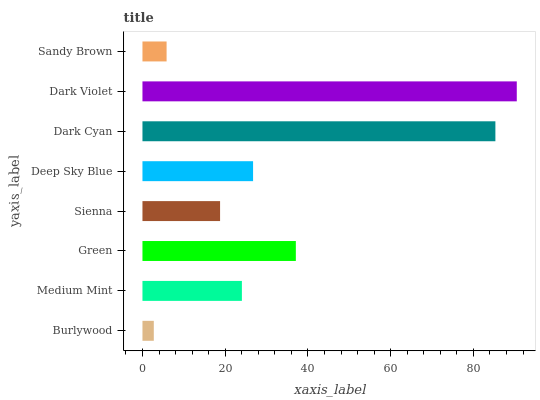Is Burlywood the minimum?
Answer yes or no. Yes. Is Dark Violet the maximum?
Answer yes or no. Yes. Is Medium Mint the minimum?
Answer yes or no. No. Is Medium Mint the maximum?
Answer yes or no. No. Is Medium Mint greater than Burlywood?
Answer yes or no. Yes. Is Burlywood less than Medium Mint?
Answer yes or no. Yes. Is Burlywood greater than Medium Mint?
Answer yes or no. No. Is Medium Mint less than Burlywood?
Answer yes or no. No. Is Deep Sky Blue the high median?
Answer yes or no. Yes. Is Medium Mint the low median?
Answer yes or no. Yes. Is Sandy Brown the high median?
Answer yes or no. No. Is Deep Sky Blue the low median?
Answer yes or no. No. 